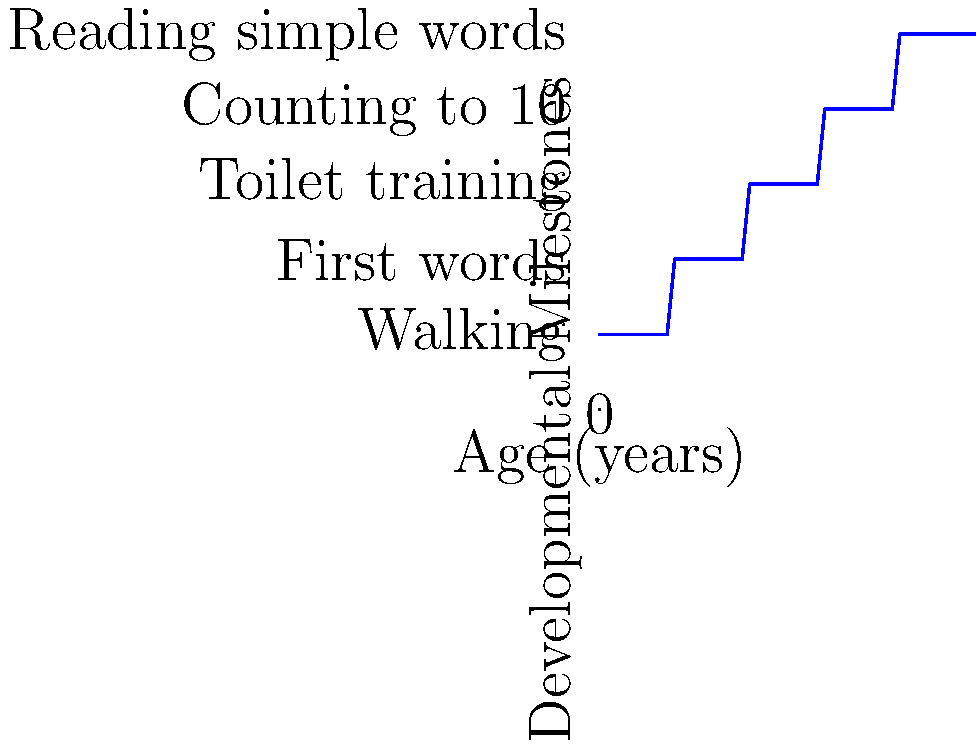Based on the step-wise function graph representing child development milestones, what is the expected age range for a child to achieve toilet training? To determine the age range for toilet training, we need to analyze the step-wise function graph:

1. The y-axis represents developmental milestones, with toilet training at level 3.
2. The x-axis represents age in years.
3. Tracing the horizontal line at y=3 (toilet training), we see it corresponds to the vertical line between x=2 and x=3.
4. This indicates that toilet training is typically achieved between 2 and 3 years of age.
5. The step function shows that this milestone is reached after the 2-year mark and before the 3-year mark.

Therefore, based on this graph, the expected age range for a child to achieve toilet training is between 2 and 3 years old.
Answer: 2-3 years 